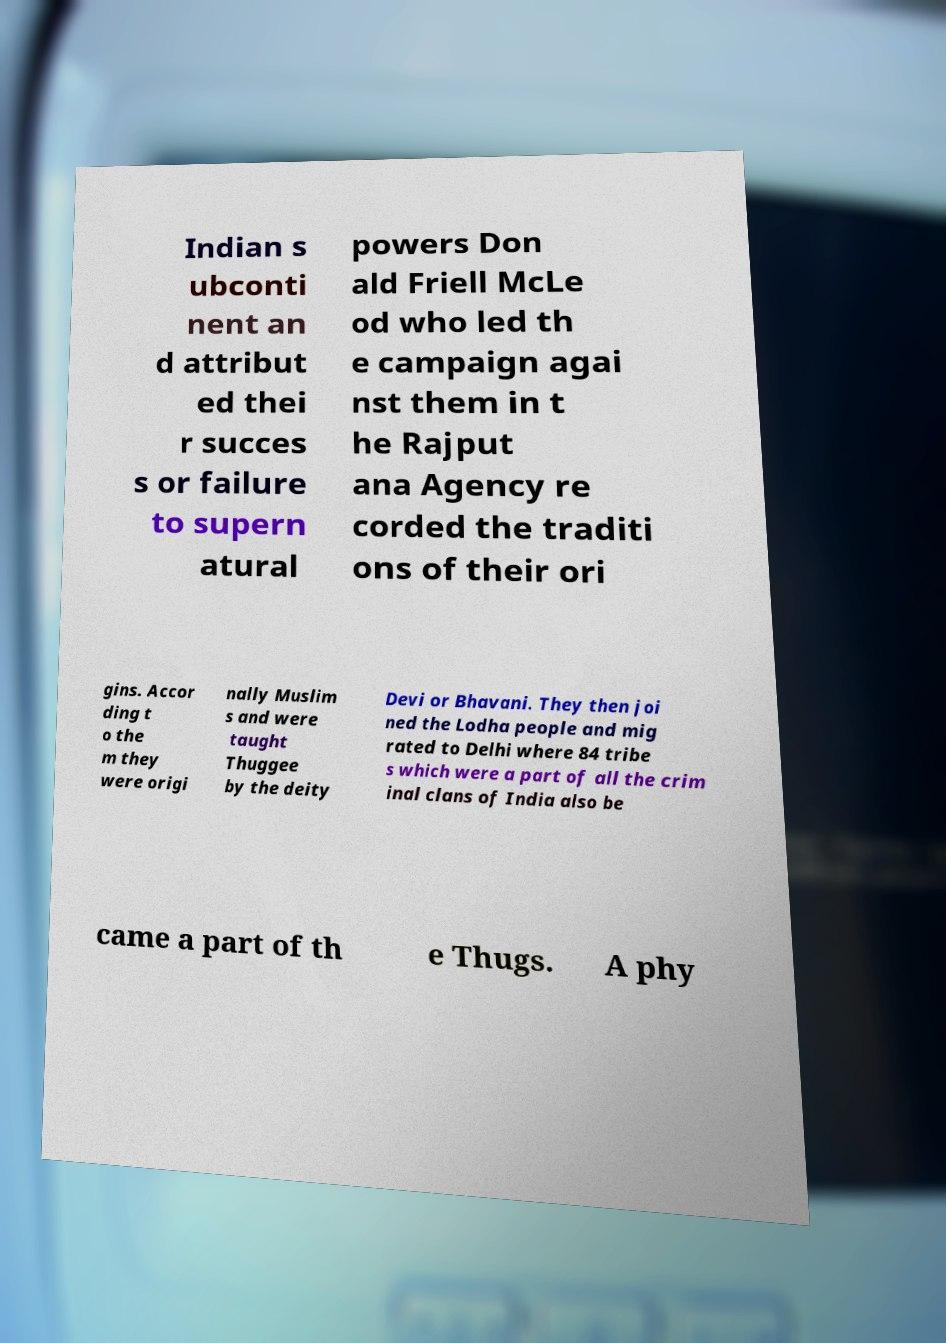I need the written content from this picture converted into text. Can you do that? Indian s ubconti nent an d attribut ed thei r succes s or failure to supern atural powers Don ald Friell McLe od who led th e campaign agai nst them in t he Rajput ana Agency re corded the traditi ons of their ori gins. Accor ding t o the m they were origi nally Muslim s and were taught Thuggee by the deity Devi or Bhavani. They then joi ned the Lodha people and mig rated to Delhi where 84 tribe s which were a part of all the crim inal clans of India also be came a part of th e Thugs. A phy 